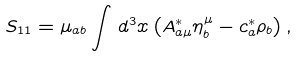Convert formula to latex. <formula><loc_0><loc_0><loc_500><loc_500>S _ { 1 1 } = \mu _ { a b } \int \, d ^ { 3 } x \left ( A _ { a \mu } ^ { * } \eta _ { b } ^ { \mu } - c _ { a } ^ { * } \rho _ { b } \right ) ,</formula> 